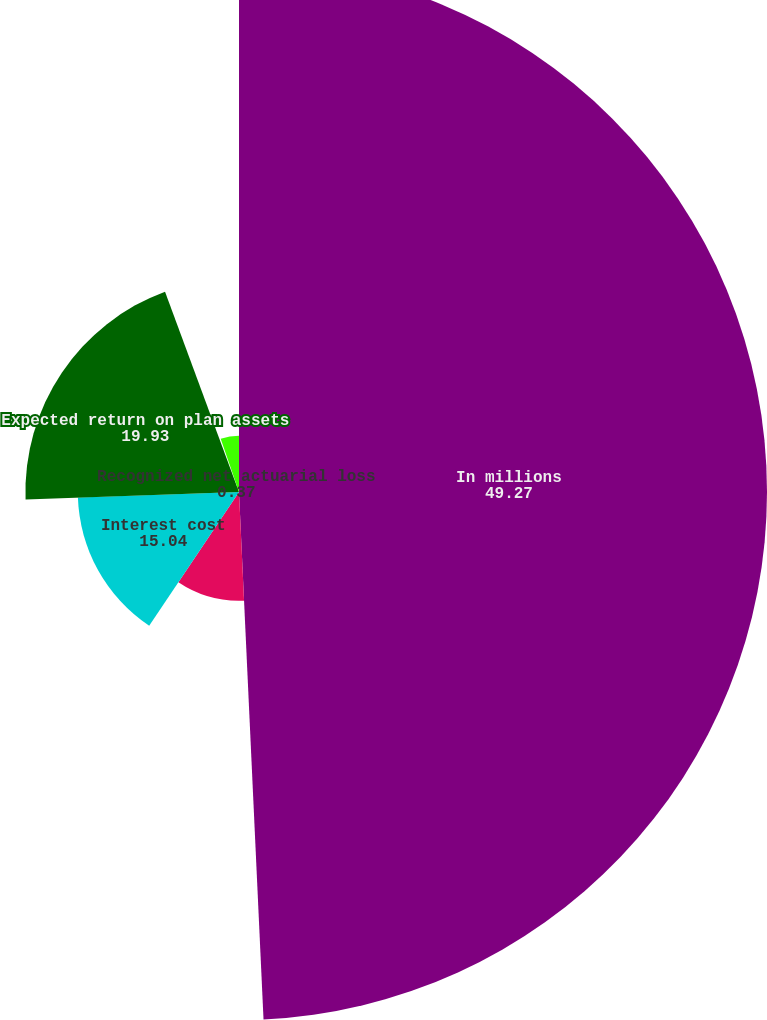Convert chart. <chart><loc_0><loc_0><loc_500><loc_500><pie_chart><fcel>In millions<fcel>Service cost<fcel>Interest cost<fcel>Expected return on plan assets<fcel>Recognized net actuarial loss<fcel>Net periodic pension cost<nl><fcel>49.27%<fcel>10.15%<fcel>15.04%<fcel>19.93%<fcel>0.37%<fcel>5.26%<nl></chart> 